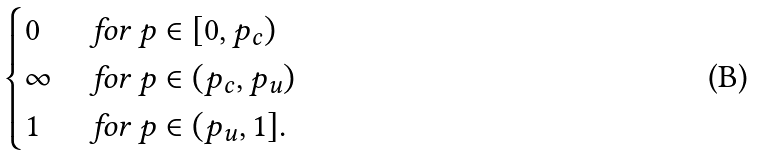<formula> <loc_0><loc_0><loc_500><loc_500>\begin{cases} 0 & \text { for } p \in [ 0 , p _ { c } ) \\ \infty & \text { for } p \in ( p _ { c } , p _ { u } ) \\ 1 & \text { for } p \in ( p _ { u } , 1 ] . \end{cases}</formula> 